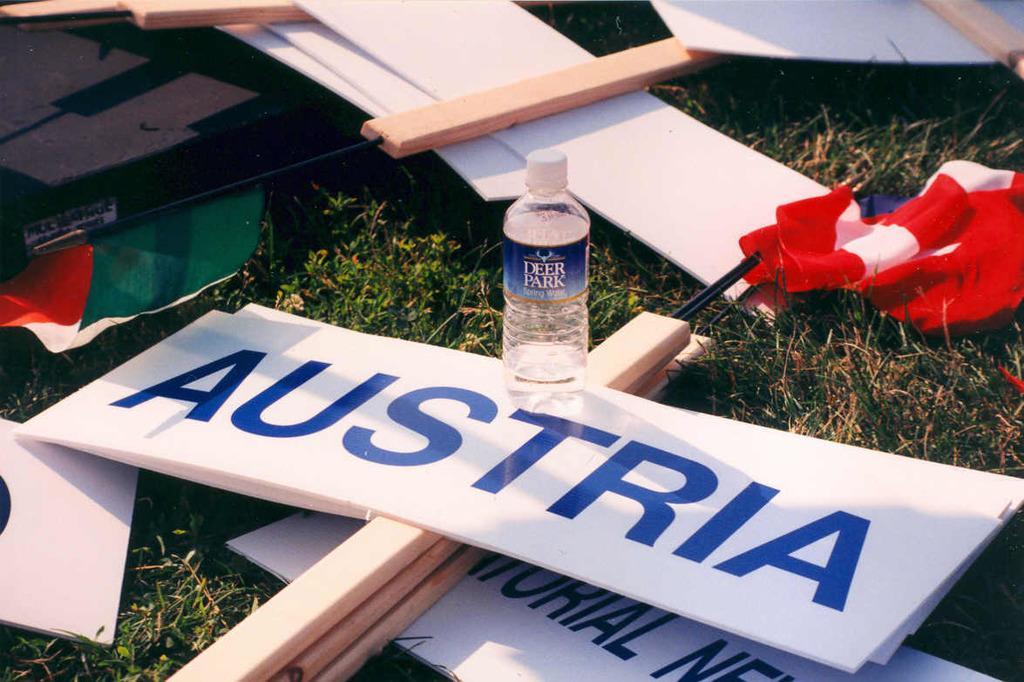Please provide a concise description of this image. We can see few boards, flags, bottle on a green grass. 